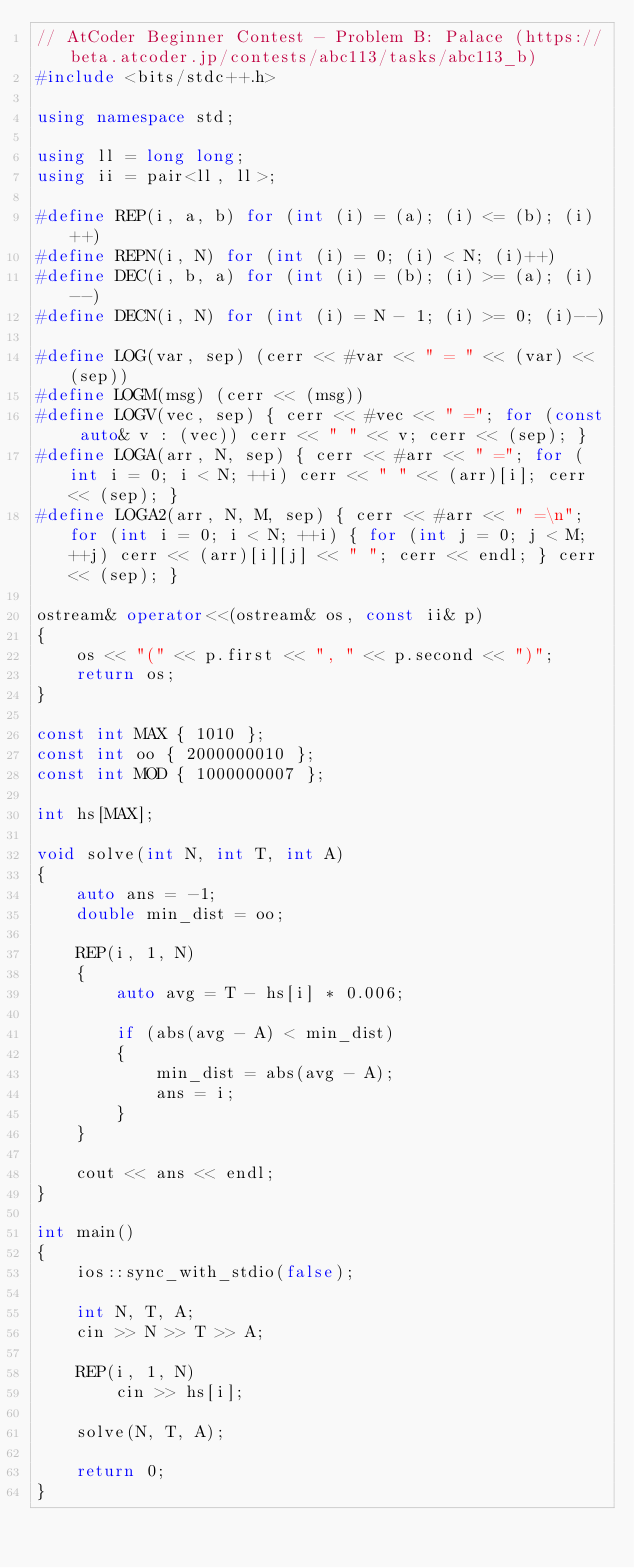Convert code to text. <code><loc_0><loc_0><loc_500><loc_500><_C++_>// AtCoder Beginner Contest - Problem B: Palace (https://beta.atcoder.jp/contests/abc113/tasks/abc113_b)
#include <bits/stdc++.h>

using namespace std;

using ll = long long;
using ii = pair<ll, ll>;

#define REP(i, a, b) for (int (i) = (a); (i) <= (b); (i)++)
#define REPN(i, N) for (int (i) = 0; (i) < N; (i)++)
#define DEC(i, b, a) for (int (i) = (b); (i) >= (a); (i)--)
#define DECN(i, N) for (int (i) = N - 1; (i) >= 0; (i)--)

#define LOG(var, sep) (cerr << #var << " = " << (var) << (sep))
#define LOGM(msg) (cerr << (msg))
#define LOGV(vec, sep) { cerr << #vec << " ="; for (const auto& v : (vec)) cerr << " " << v; cerr << (sep); }
#define LOGA(arr, N, sep) { cerr << #arr << " ="; for (int i = 0; i < N; ++i) cerr << " " << (arr)[i]; cerr << (sep); }
#define LOGA2(arr, N, M, sep) { cerr << #arr << " =\n"; for (int i = 0; i < N; ++i) { for (int j = 0; j < M; ++j) cerr << (arr)[i][j] << " "; cerr << endl; } cerr << (sep); }

ostream& operator<<(ostream& os, const ii& p)
{
    os << "(" << p.first << ", " << p.second << ")";
    return os;
}

const int MAX { 1010 };
const int oo { 2000000010 };
const int MOD { 1000000007 };

int hs[MAX];

void solve(int N, int T, int A)
{
    auto ans = -1;
    double min_dist = oo;

    REP(i, 1, N)
    {
        auto avg = T - hs[i] * 0.006;

        if (abs(avg - A) < min_dist)
        {
            min_dist = abs(avg - A);
            ans = i;
        }
    }

    cout << ans << endl;
}

int main()
{
    ios::sync_with_stdio(false);

    int N, T, A;
    cin >> N >> T >> A;

    REP(i, 1, N)
        cin >> hs[i];

    solve(N, T, A);

    return 0;
}
</code> 